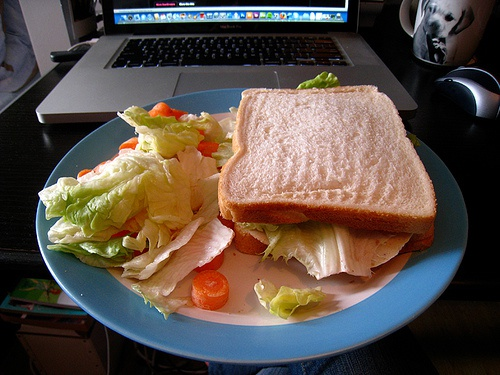Describe the objects in this image and their specific colors. I can see sandwich in black, tan, maroon, and lightgray tones, laptop in black, gray, and white tones, cup in black, gray, and darkgray tones, mouse in black, gray, and lavender tones, and carrot in black, brown, and red tones in this image. 